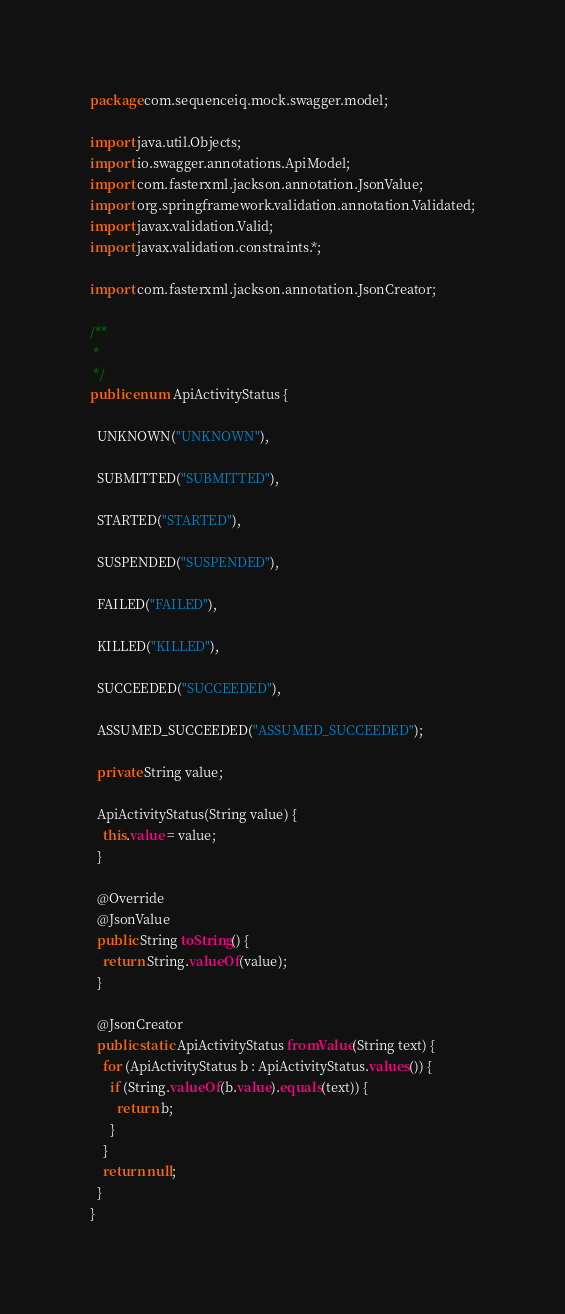Convert code to text. <code><loc_0><loc_0><loc_500><loc_500><_Java_>package com.sequenceiq.mock.swagger.model;

import java.util.Objects;
import io.swagger.annotations.ApiModel;
import com.fasterxml.jackson.annotation.JsonValue;
import org.springframework.validation.annotation.Validated;
import javax.validation.Valid;
import javax.validation.constraints.*;

import com.fasterxml.jackson.annotation.JsonCreator;

/**
 * 
 */
public enum ApiActivityStatus {
  
  UNKNOWN("UNKNOWN"),
  
  SUBMITTED("SUBMITTED"),
  
  STARTED("STARTED"),
  
  SUSPENDED("SUSPENDED"),
  
  FAILED("FAILED"),
  
  KILLED("KILLED"),
  
  SUCCEEDED("SUCCEEDED"),
  
  ASSUMED_SUCCEEDED("ASSUMED_SUCCEEDED");

  private String value;

  ApiActivityStatus(String value) {
    this.value = value;
  }

  @Override
  @JsonValue
  public String toString() {
    return String.valueOf(value);
  }

  @JsonCreator
  public static ApiActivityStatus fromValue(String text) {
    for (ApiActivityStatus b : ApiActivityStatus.values()) {
      if (String.valueOf(b.value).equals(text)) {
        return b;
      }
    }
    return null;
  }
}

</code> 